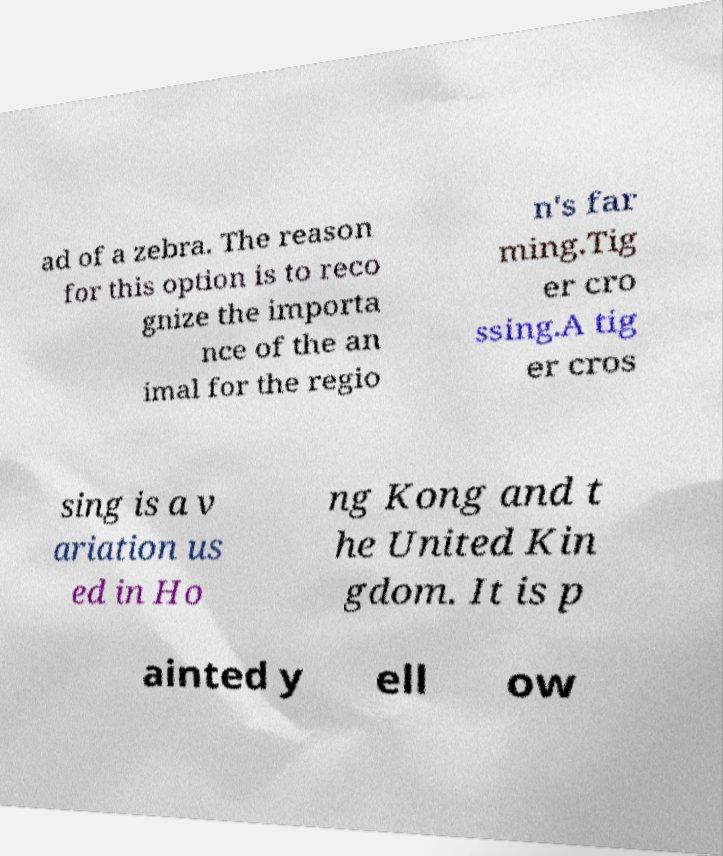Could you assist in decoding the text presented in this image and type it out clearly? ad of a zebra. The reason for this option is to reco gnize the importa nce of the an imal for the regio n's far ming.Tig er cro ssing.A tig er cros sing is a v ariation us ed in Ho ng Kong and t he United Kin gdom. It is p ainted y ell ow 